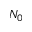<formula> <loc_0><loc_0><loc_500><loc_500>N _ { 0 }</formula> 